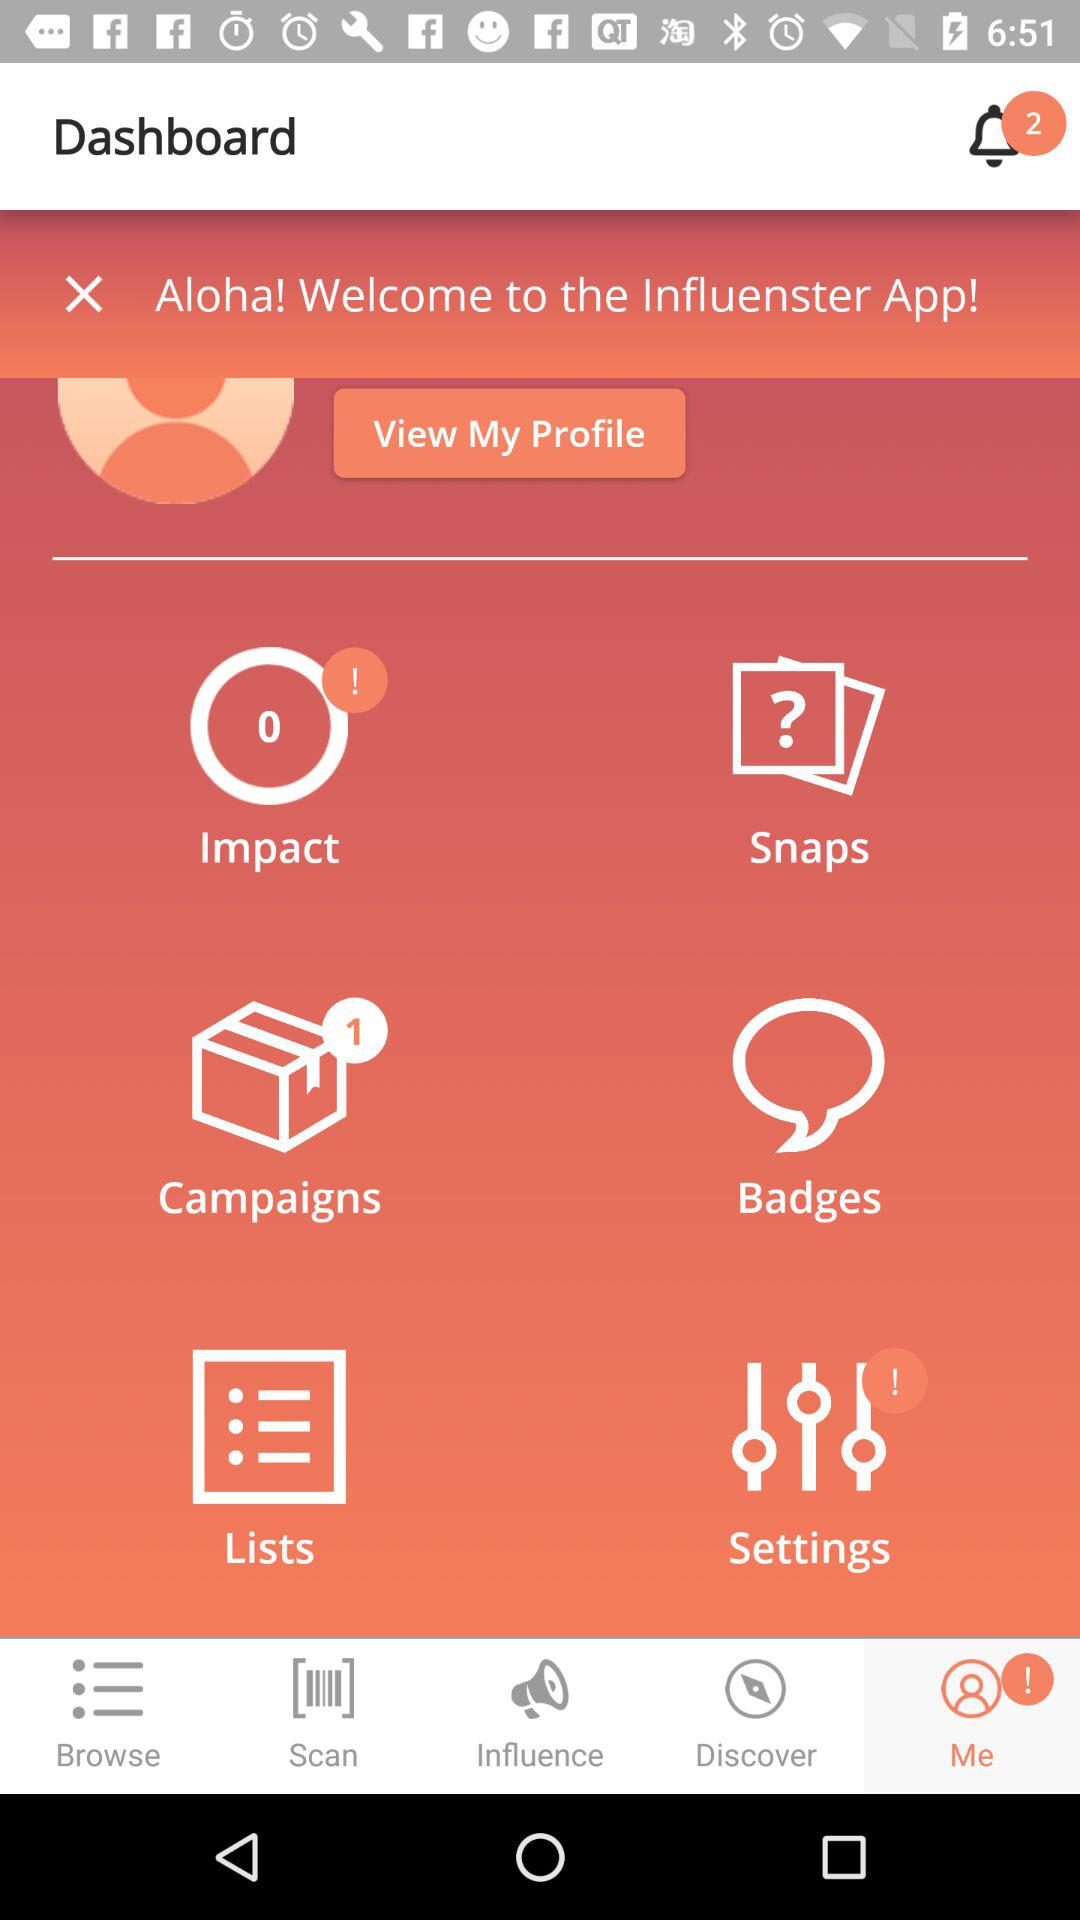How many badges does the user have?
When the provided information is insufficient, respond with <no answer>. <no answer> 